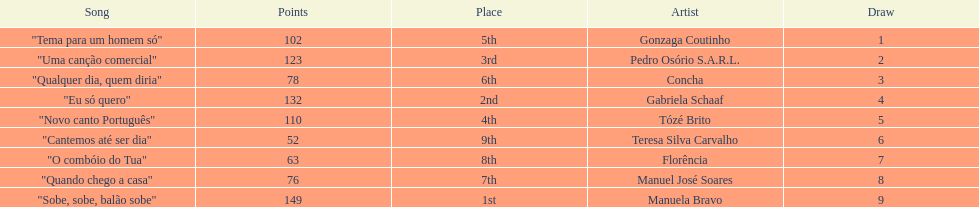Who was the last draw? Manuela Bravo. 